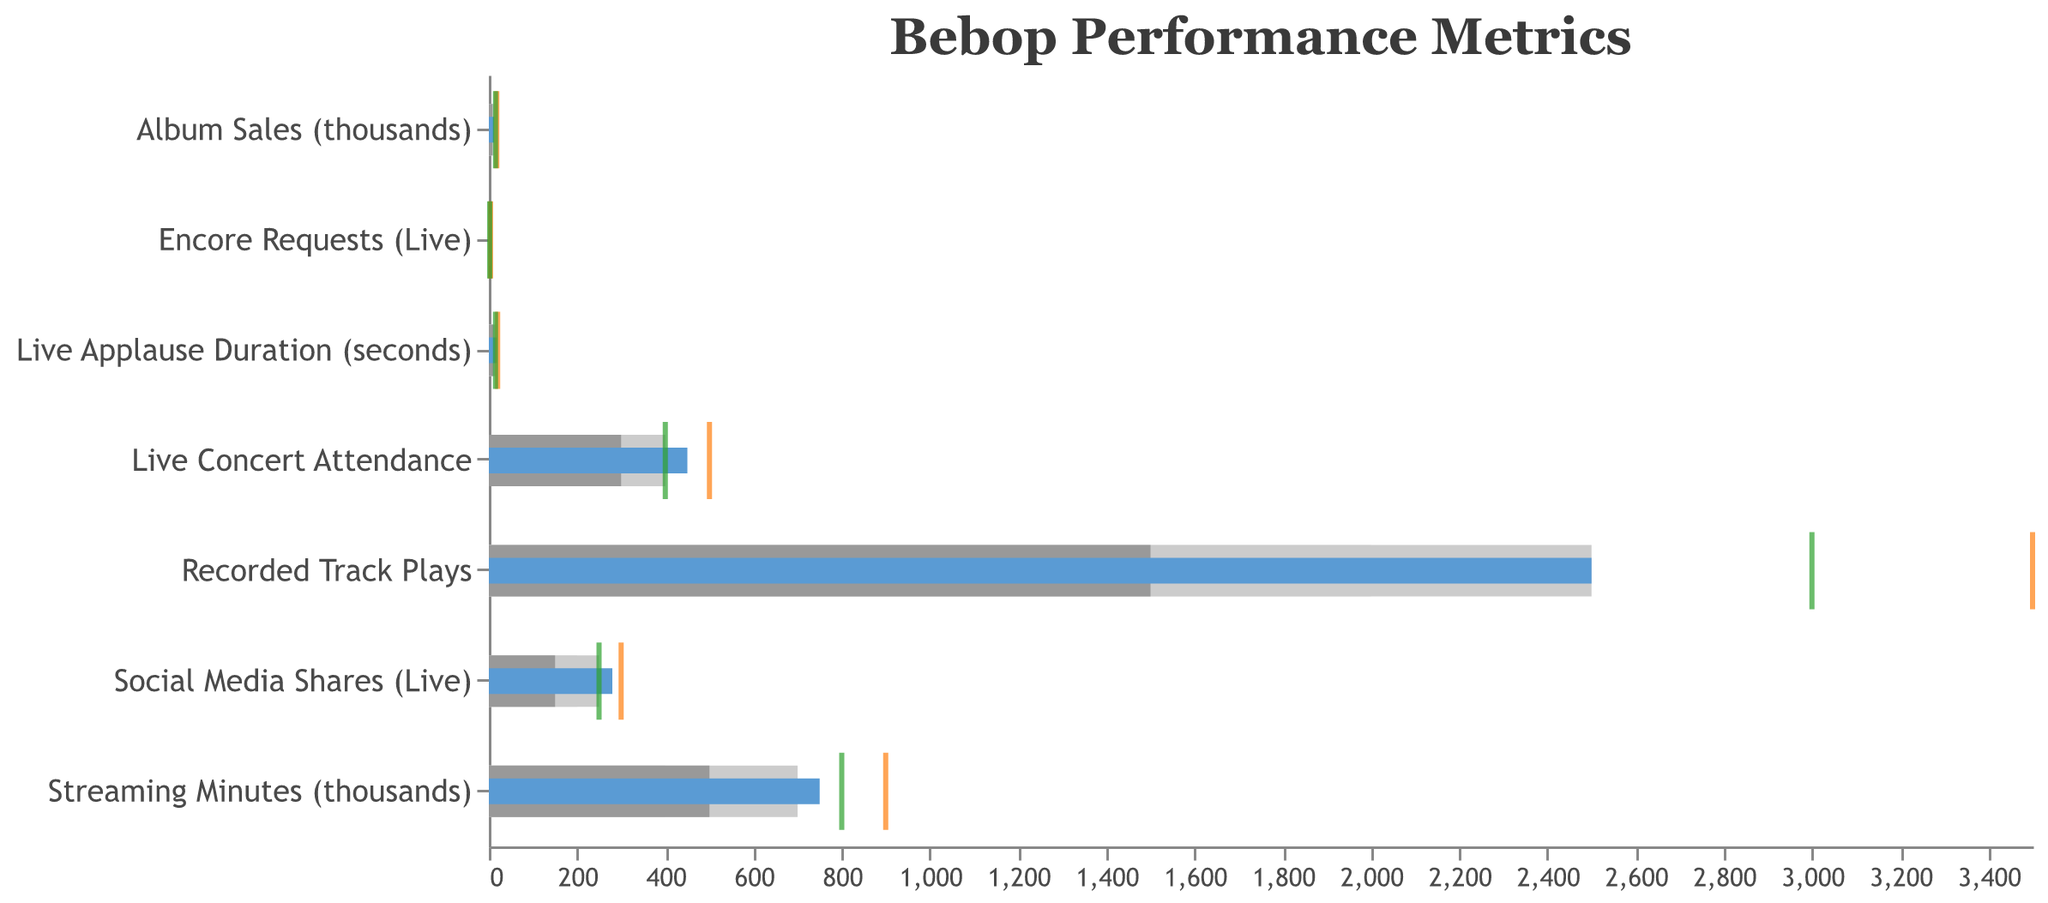What's the title of the chart? The title of the chart is mentioned at the very top of the figure.
Answer: Bebop Performance Metrics How does the actual value of "Recorded Track Plays" compare to its target? The blue bar (actual value) is shorter than the orange tick mark (target), indicating the actual value is less than the target.
Answer: Less than target What's the difference between the actual and comparative values for "Social Media Shares (Live)"? The actual value of "Social Media Shares (Live)" is 280, while the comparative value is 250. The difference is calculated by subtracting the comparative from the actual (280 - 250).
Answer: 30 Which metric has the highest "Target" value, and what is that value? The largest orange tick mark in the figure, indicating the highest target value, belongs to "Streaming Minutes (thousands)" at 900,000 minutes.
Answer: Streaming Minutes (thousands), 900 How close is the "Live Applause Duration" to its target value? The actual value of "Live Applause Duration" is 18 seconds, and the target is 20 seconds. The difference is 2 seconds (20 - 18).
Answer: 2 seconds Is the "Live Concert Attendance" meeting the target? The actual bar (blue) reaches 450, which meets the target mark (orange tick) set at 500. So, it is less than the target.
Answer: Less than target What is the sum of the actual values for "Live Applause Duration" and "Encore Requests (Live)"? The actual values are 18 and 3, respectively. The sum is calculated by adding 18 and 3 (18 + 3).
Answer: 21 Which metric has the closest actual value to its comparative value? By comparing the blue bars and green tick marks, "Encore Requests (Live)" has the closest values with 3 (actual) and 2 (comparative).
Answer: Encore Requests (Live) How does the "Album Sales (thousands)" actual value compare to its target and comparative values? The actual value is 12, which is less than both its comparative value (15) and its target (18).
Answer: Less than both What's the total of the target values for "Live Applause Duration" and "Live Concert Attendance"? The target values are 20 for "Live Applause Duration" and 500 for "Live Concert Attendance". Summing these values (20 + 500) gives 520.
Answer: 520 